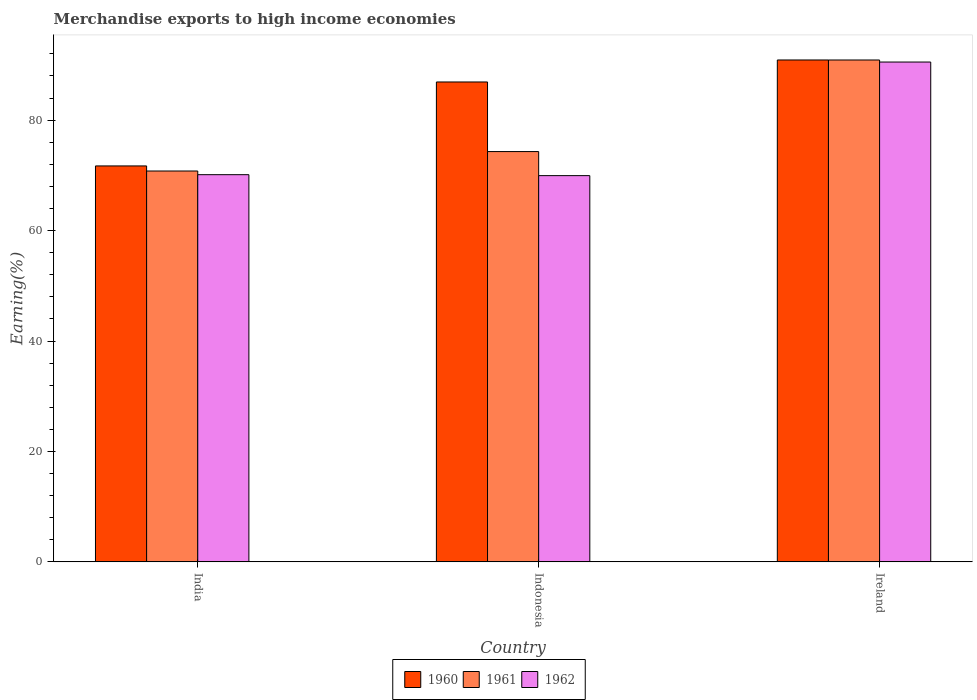How many different coloured bars are there?
Offer a very short reply. 3. Are the number of bars per tick equal to the number of legend labels?
Offer a terse response. Yes. How many bars are there on the 1st tick from the left?
Provide a succinct answer. 3. What is the label of the 3rd group of bars from the left?
Your response must be concise. Ireland. In how many cases, is the number of bars for a given country not equal to the number of legend labels?
Your response must be concise. 0. What is the percentage of amount earned from merchandise exports in 1961 in Ireland?
Your answer should be compact. 90.9. Across all countries, what is the maximum percentage of amount earned from merchandise exports in 1962?
Your answer should be compact. 90.53. Across all countries, what is the minimum percentage of amount earned from merchandise exports in 1960?
Give a very brief answer. 71.71. In which country was the percentage of amount earned from merchandise exports in 1962 maximum?
Give a very brief answer. Ireland. In which country was the percentage of amount earned from merchandise exports in 1961 minimum?
Give a very brief answer. India. What is the total percentage of amount earned from merchandise exports in 1960 in the graph?
Your response must be concise. 249.53. What is the difference between the percentage of amount earned from merchandise exports in 1962 in India and that in Ireland?
Offer a terse response. -20.4. What is the difference between the percentage of amount earned from merchandise exports in 1961 in India and the percentage of amount earned from merchandise exports in 1962 in Indonesia?
Your answer should be very brief. 0.84. What is the average percentage of amount earned from merchandise exports in 1962 per country?
Provide a short and direct response. 76.87. What is the difference between the percentage of amount earned from merchandise exports of/in 1962 and percentage of amount earned from merchandise exports of/in 1960 in India?
Provide a succinct answer. -1.58. What is the ratio of the percentage of amount earned from merchandise exports in 1961 in Indonesia to that in Ireland?
Your response must be concise. 0.82. Is the percentage of amount earned from merchandise exports in 1961 in India less than that in Ireland?
Offer a very short reply. Yes. Is the difference between the percentage of amount earned from merchandise exports in 1962 in India and Indonesia greater than the difference between the percentage of amount earned from merchandise exports in 1960 in India and Indonesia?
Make the answer very short. Yes. What is the difference between the highest and the second highest percentage of amount earned from merchandise exports in 1961?
Provide a short and direct response. 16.58. What is the difference between the highest and the lowest percentage of amount earned from merchandise exports in 1961?
Offer a very short reply. 20.11. Is it the case that in every country, the sum of the percentage of amount earned from merchandise exports in 1961 and percentage of amount earned from merchandise exports in 1962 is greater than the percentage of amount earned from merchandise exports in 1960?
Offer a very short reply. Yes. Are all the bars in the graph horizontal?
Your answer should be compact. No. How many countries are there in the graph?
Ensure brevity in your answer.  3. Are the values on the major ticks of Y-axis written in scientific E-notation?
Ensure brevity in your answer.  No. Does the graph contain grids?
Your response must be concise. No. Where does the legend appear in the graph?
Your answer should be very brief. Bottom center. How many legend labels are there?
Provide a short and direct response. 3. How are the legend labels stacked?
Your response must be concise. Horizontal. What is the title of the graph?
Keep it short and to the point. Merchandise exports to high income economies. What is the label or title of the Y-axis?
Your answer should be very brief. Earning(%). What is the Earning(%) in 1960 in India?
Make the answer very short. 71.71. What is the Earning(%) of 1961 in India?
Ensure brevity in your answer.  70.79. What is the Earning(%) in 1962 in India?
Offer a very short reply. 70.13. What is the Earning(%) of 1960 in Indonesia?
Make the answer very short. 86.92. What is the Earning(%) of 1961 in Indonesia?
Keep it short and to the point. 74.31. What is the Earning(%) of 1962 in Indonesia?
Give a very brief answer. 69.95. What is the Earning(%) of 1960 in Ireland?
Make the answer very short. 90.9. What is the Earning(%) in 1961 in Ireland?
Your response must be concise. 90.9. What is the Earning(%) of 1962 in Ireland?
Give a very brief answer. 90.53. Across all countries, what is the maximum Earning(%) in 1960?
Your answer should be compact. 90.9. Across all countries, what is the maximum Earning(%) in 1961?
Make the answer very short. 90.9. Across all countries, what is the maximum Earning(%) in 1962?
Your response must be concise. 90.53. Across all countries, what is the minimum Earning(%) of 1960?
Your answer should be compact. 71.71. Across all countries, what is the minimum Earning(%) in 1961?
Your response must be concise. 70.79. Across all countries, what is the minimum Earning(%) in 1962?
Offer a very short reply. 69.95. What is the total Earning(%) in 1960 in the graph?
Provide a short and direct response. 249.53. What is the total Earning(%) of 1961 in the graph?
Offer a terse response. 236. What is the total Earning(%) in 1962 in the graph?
Keep it short and to the point. 230.6. What is the difference between the Earning(%) in 1960 in India and that in Indonesia?
Your answer should be very brief. -15.21. What is the difference between the Earning(%) in 1961 in India and that in Indonesia?
Offer a terse response. -3.52. What is the difference between the Earning(%) in 1962 in India and that in Indonesia?
Make the answer very short. 0.17. What is the difference between the Earning(%) of 1960 in India and that in Ireland?
Provide a short and direct response. -19.19. What is the difference between the Earning(%) of 1961 in India and that in Ireland?
Ensure brevity in your answer.  -20.11. What is the difference between the Earning(%) in 1962 in India and that in Ireland?
Offer a terse response. -20.4. What is the difference between the Earning(%) in 1960 in Indonesia and that in Ireland?
Ensure brevity in your answer.  -3.98. What is the difference between the Earning(%) in 1961 in Indonesia and that in Ireland?
Offer a terse response. -16.58. What is the difference between the Earning(%) in 1962 in Indonesia and that in Ireland?
Your answer should be very brief. -20.57. What is the difference between the Earning(%) in 1960 in India and the Earning(%) in 1961 in Indonesia?
Give a very brief answer. -2.6. What is the difference between the Earning(%) of 1960 in India and the Earning(%) of 1962 in Indonesia?
Give a very brief answer. 1.76. What is the difference between the Earning(%) of 1961 in India and the Earning(%) of 1962 in Indonesia?
Give a very brief answer. 0.84. What is the difference between the Earning(%) of 1960 in India and the Earning(%) of 1961 in Ireland?
Offer a terse response. -19.19. What is the difference between the Earning(%) in 1960 in India and the Earning(%) in 1962 in Ireland?
Your answer should be compact. -18.82. What is the difference between the Earning(%) in 1961 in India and the Earning(%) in 1962 in Ireland?
Your answer should be compact. -19.74. What is the difference between the Earning(%) in 1960 in Indonesia and the Earning(%) in 1961 in Ireland?
Offer a terse response. -3.98. What is the difference between the Earning(%) of 1960 in Indonesia and the Earning(%) of 1962 in Ireland?
Ensure brevity in your answer.  -3.61. What is the difference between the Earning(%) in 1961 in Indonesia and the Earning(%) in 1962 in Ireland?
Give a very brief answer. -16.21. What is the average Earning(%) in 1960 per country?
Offer a very short reply. 83.18. What is the average Earning(%) in 1961 per country?
Offer a very short reply. 78.67. What is the average Earning(%) of 1962 per country?
Ensure brevity in your answer.  76.87. What is the difference between the Earning(%) of 1960 and Earning(%) of 1961 in India?
Offer a terse response. 0.92. What is the difference between the Earning(%) in 1960 and Earning(%) in 1962 in India?
Keep it short and to the point. 1.58. What is the difference between the Earning(%) of 1961 and Earning(%) of 1962 in India?
Make the answer very short. 0.66. What is the difference between the Earning(%) of 1960 and Earning(%) of 1961 in Indonesia?
Provide a succinct answer. 12.6. What is the difference between the Earning(%) of 1960 and Earning(%) of 1962 in Indonesia?
Keep it short and to the point. 16.96. What is the difference between the Earning(%) of 1961 and Earning(%) of 1962 in Indonesia?
Keep it short and to the point. 4.36. What is the difference between the Earning(%) of 1960 and Earning(%) of 1961 in Ireland?
Your response must be concise. 0. What is the difference between the Earning(%) of 1960 and Earning(%) of 1962 in Ireland?
Your answer should be very brief. 0.37. What is the difference between the Earning(%) of 1961 and Earning(%) of 1962 in Ireland?
Your answer should be very brief. 0.37. What is the ratio of the Earning(%) in 1960 in India to that in Indonesia?
Provide a succinct answer. 0.82. What is the ratio of the Earning(%) of 1961 in India to that in Indonesia?
Provide a short and direct response. 0.95. What is the ratio of the Earning(%) of 1960 in India to that in Ireland?
Give a very brief answer. 0.79. What is the ratio of the Earning(%) of 1961 in India to that in Ireland?
Offer a very short reply. 0.78. What is the ratio of the Earning(%) in 1962 in India to that in Ireland?
Make the answer very short. 0.77. What is the ratio of the Earning(%) of 1960 in Indonesia to that in Ireland?
Provide a short and direct response. 0.96. What is the ratio of the Earning(%) in 1961 in Indonesia to that in Ireland?
Provide a succinct answer. 0.82. What is the ratio of the Earning(%) of 1962 in Indonesia to that in Ireland?
Your answer should be very brief. 0.77. What is the difference between the highest and the second highest Earning(%) in 1960?
Make the answer very short. 3.98. What is the difference between the highest and the second highest Earning(%) in 1961?
Keep it short and to the point. 16.58. What is the difference between the highest and the second highest Earning(%) of 1962?
Your answer should be compact. 20.4. What is the difference between the highest and the lowest Earning(%) in 1960?
Keep it short and to the point. 19.19. What is the difference between the highest and the lowest Earning(%) of 1961?
Provide a short and direct response. 20.11. What is the difference between the highest and the lowest Earning(%) in 1962?
Offer a terse response. 20.57. 